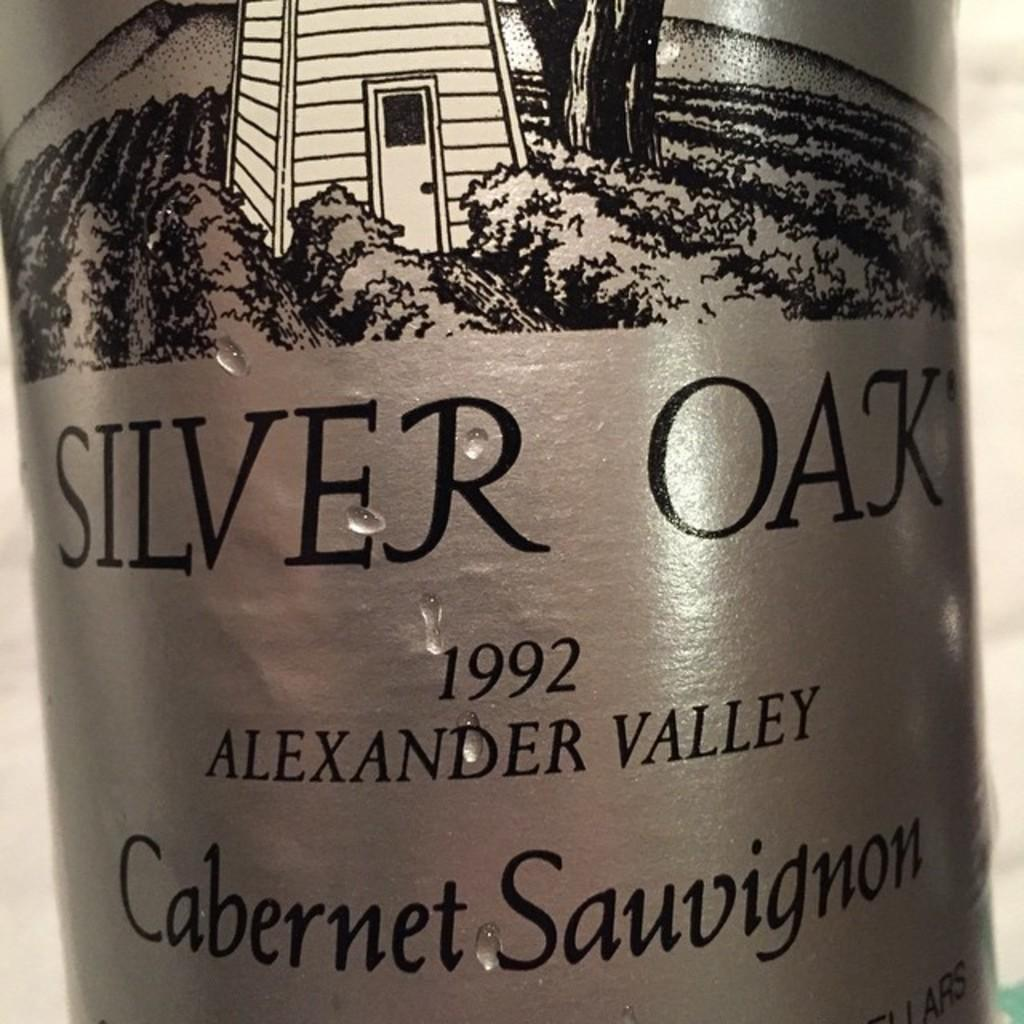Provide a one-sentence caption for the provided image. Silver Oak's 1992 cabernet sauvignon has a silver label with a picture of a vineyard on it. 